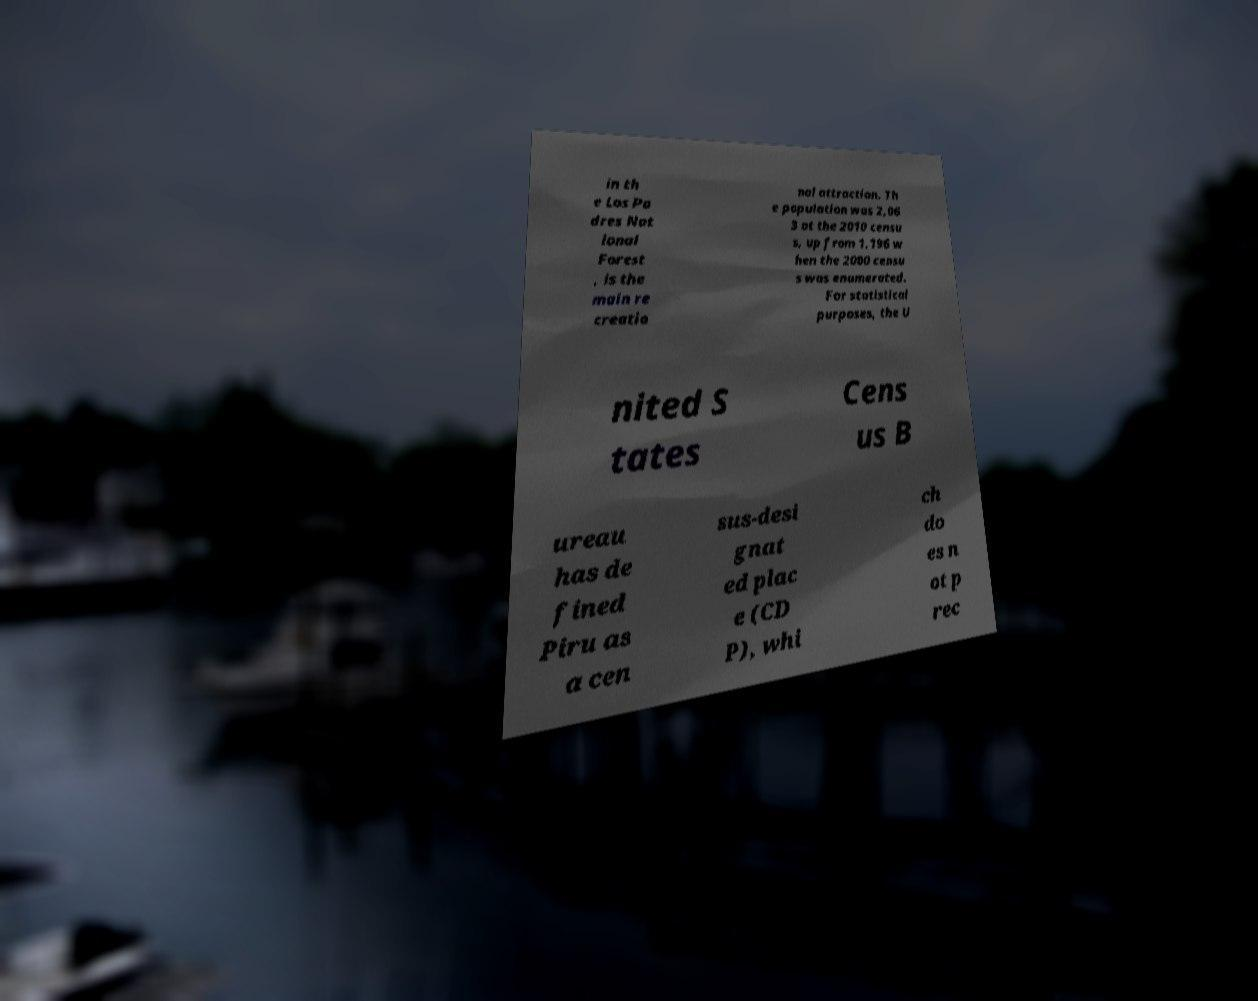Could you extract and type out the text from this image? in th e Los Pa dres Nat ional Forest , is the main re creatio nal attraction. Th e population was 2,06 3 at the 2010 censu s, up from 1,196 w hen the 2000 censu s was enumerated. For statistical purposes, the U nited S tates Cens us B ureau has de fined Piru as a cen sus-desi gnat ed plac e (CD P), whi ch do es n ot p rec 